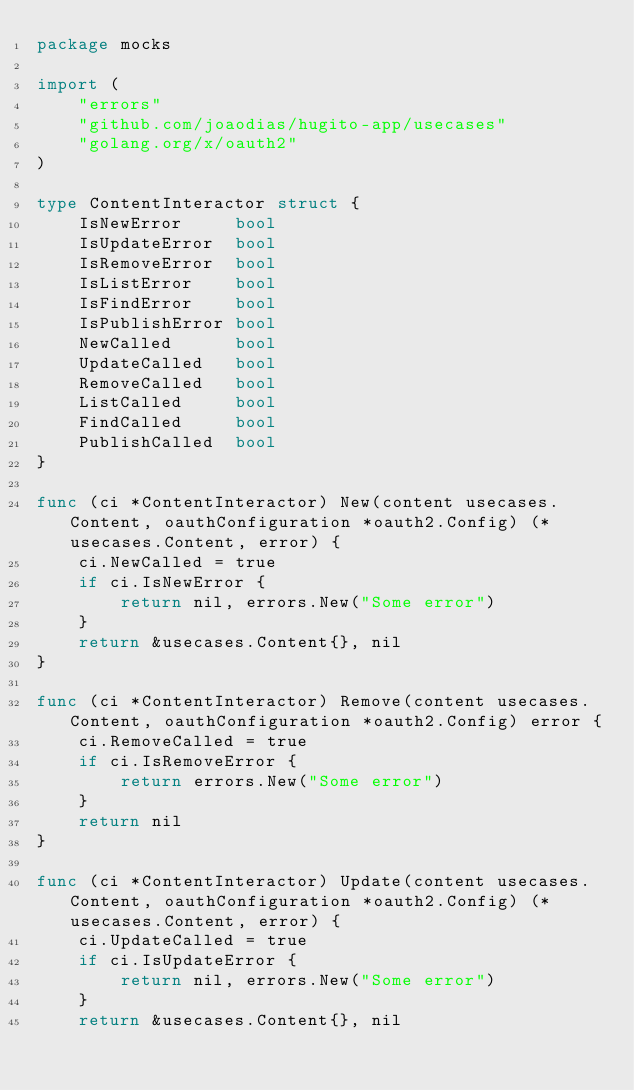Convert code to text. <code><loc_0><loc_0><loc_500><loc_500><_Go_>package mocks

import (
	"errors"
	"github.com/joaodias/hugito-app/usecases"
	"golang.org/x/oauth2"
)

type ContentInteractor struct {
	IsNewError     bool
	IsUpdateError  bool
	IsRemoveError  bool
	IsListError    bool
	IsFindError    bool
	IsPublishError bool
	NewCalled      bool
	UpdateCalled   bool
	RemoveCalled   bool
	ListCalled     bool
	FindCalled     bool
	PublishCalled  bool
}

func (ci *ContentInteractor) New(content usecases.Content, oauthConfiguration *oauth2.Config) (*usecases.Content, error) {
	ci.NewCalled = true
	if ci.IsNewError {
		return nil, errors.New("Some error")
	}
	return &usecases.Content{}, nil
}

func (ci *ContentInteractor) Remove(content usecases.Content, oauthConfiguration *oauth2.Config) error {
	ci.RemoveCalled = true
	if ci.IsRemoveError {
		return errors.New("Some error")
	}
	return nil
}

func (ci *ContentInteractor) Update(content usecases.Content, oauthConfiguration *oauth2.Config) (*usecases.Content, error) {
	ci.UpdateCalled = true
	if ci.IsUpdateError {
		return nil, errors.New("Some error")
	}
	return &usecases.Content{}, nil</code> 